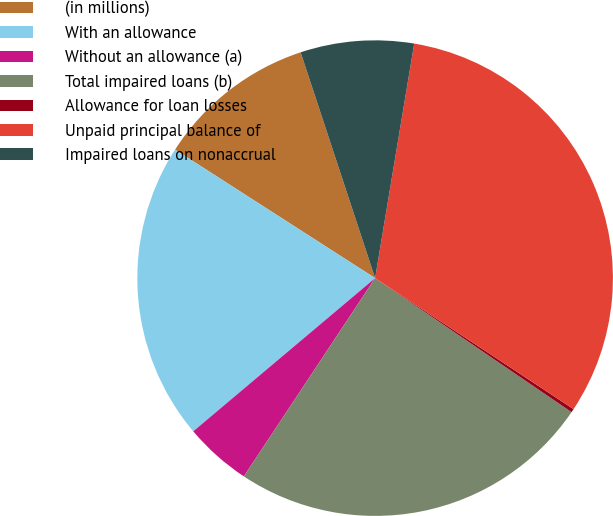Convert chart. <chart><loc_0><loc_0><loc_500><loc_500><pie_chart><fcel>(in millions)<fcel>With an allowance<fcel>Without an allowance (a)<fcel>Total impaired loans (b)<fcel>Allowance for loan losses<fcel>Unpaid principal balance of<fcel>Impaired loans on nonaccrual<nl><fcel>10.84%<fcel>20.23%<fcel>4.55%<fcel>24.78%<fcel>0.24%<fcel>31.66%<fcel>7.7%<nl></chart> 